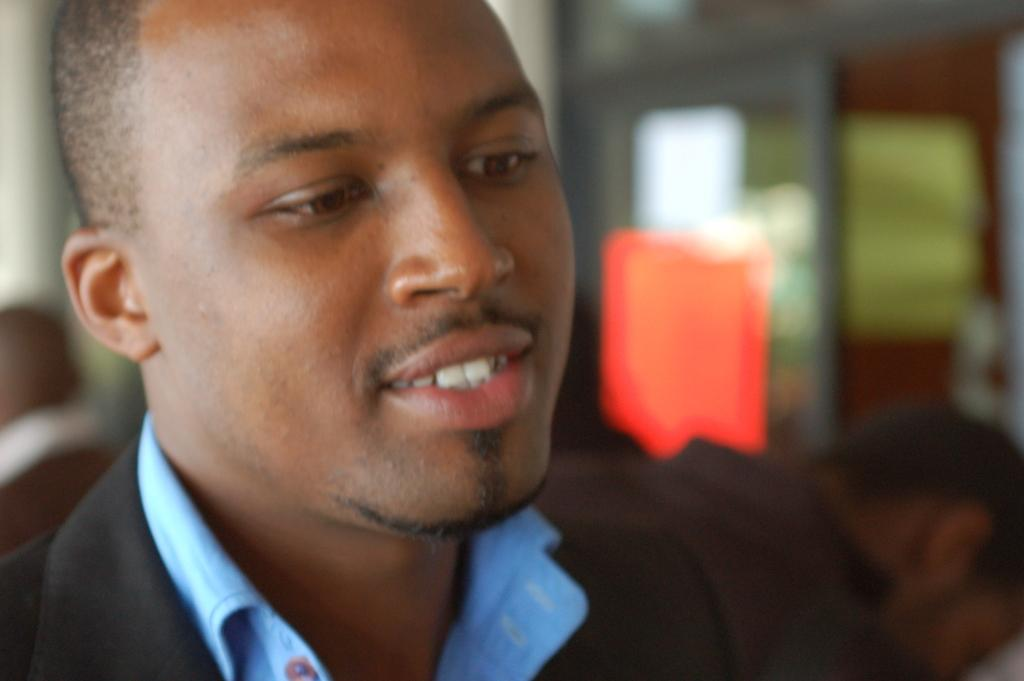Who or what is the main subject in the front of the image? There is a person in the front of the image. What can be observed about the background of the image? The background of the image is blurry. Can you describe the people visible in the background of the image? There are people visible in the background of the image. How many ducks are visible in the image? There are no ducks present in the image. What is the way the person in the front was born? The image does not provide any information about the person's birth, so it cannot be determined from the image. 